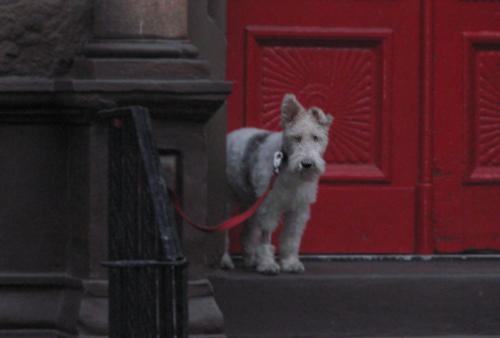Is this animal fluffy?
Answer briefly. Yes. What color is the door?
Keep it brief. Red. What animal is this?
Keep it brief. Dog. Is the dog missing some fur?
Keep it brief. Yes. What breed of dog is this?
Keep it brief. Terrier. What animal is in the photo?
Keep it brief. Dog. What is this?
Be succinct. Dog. 